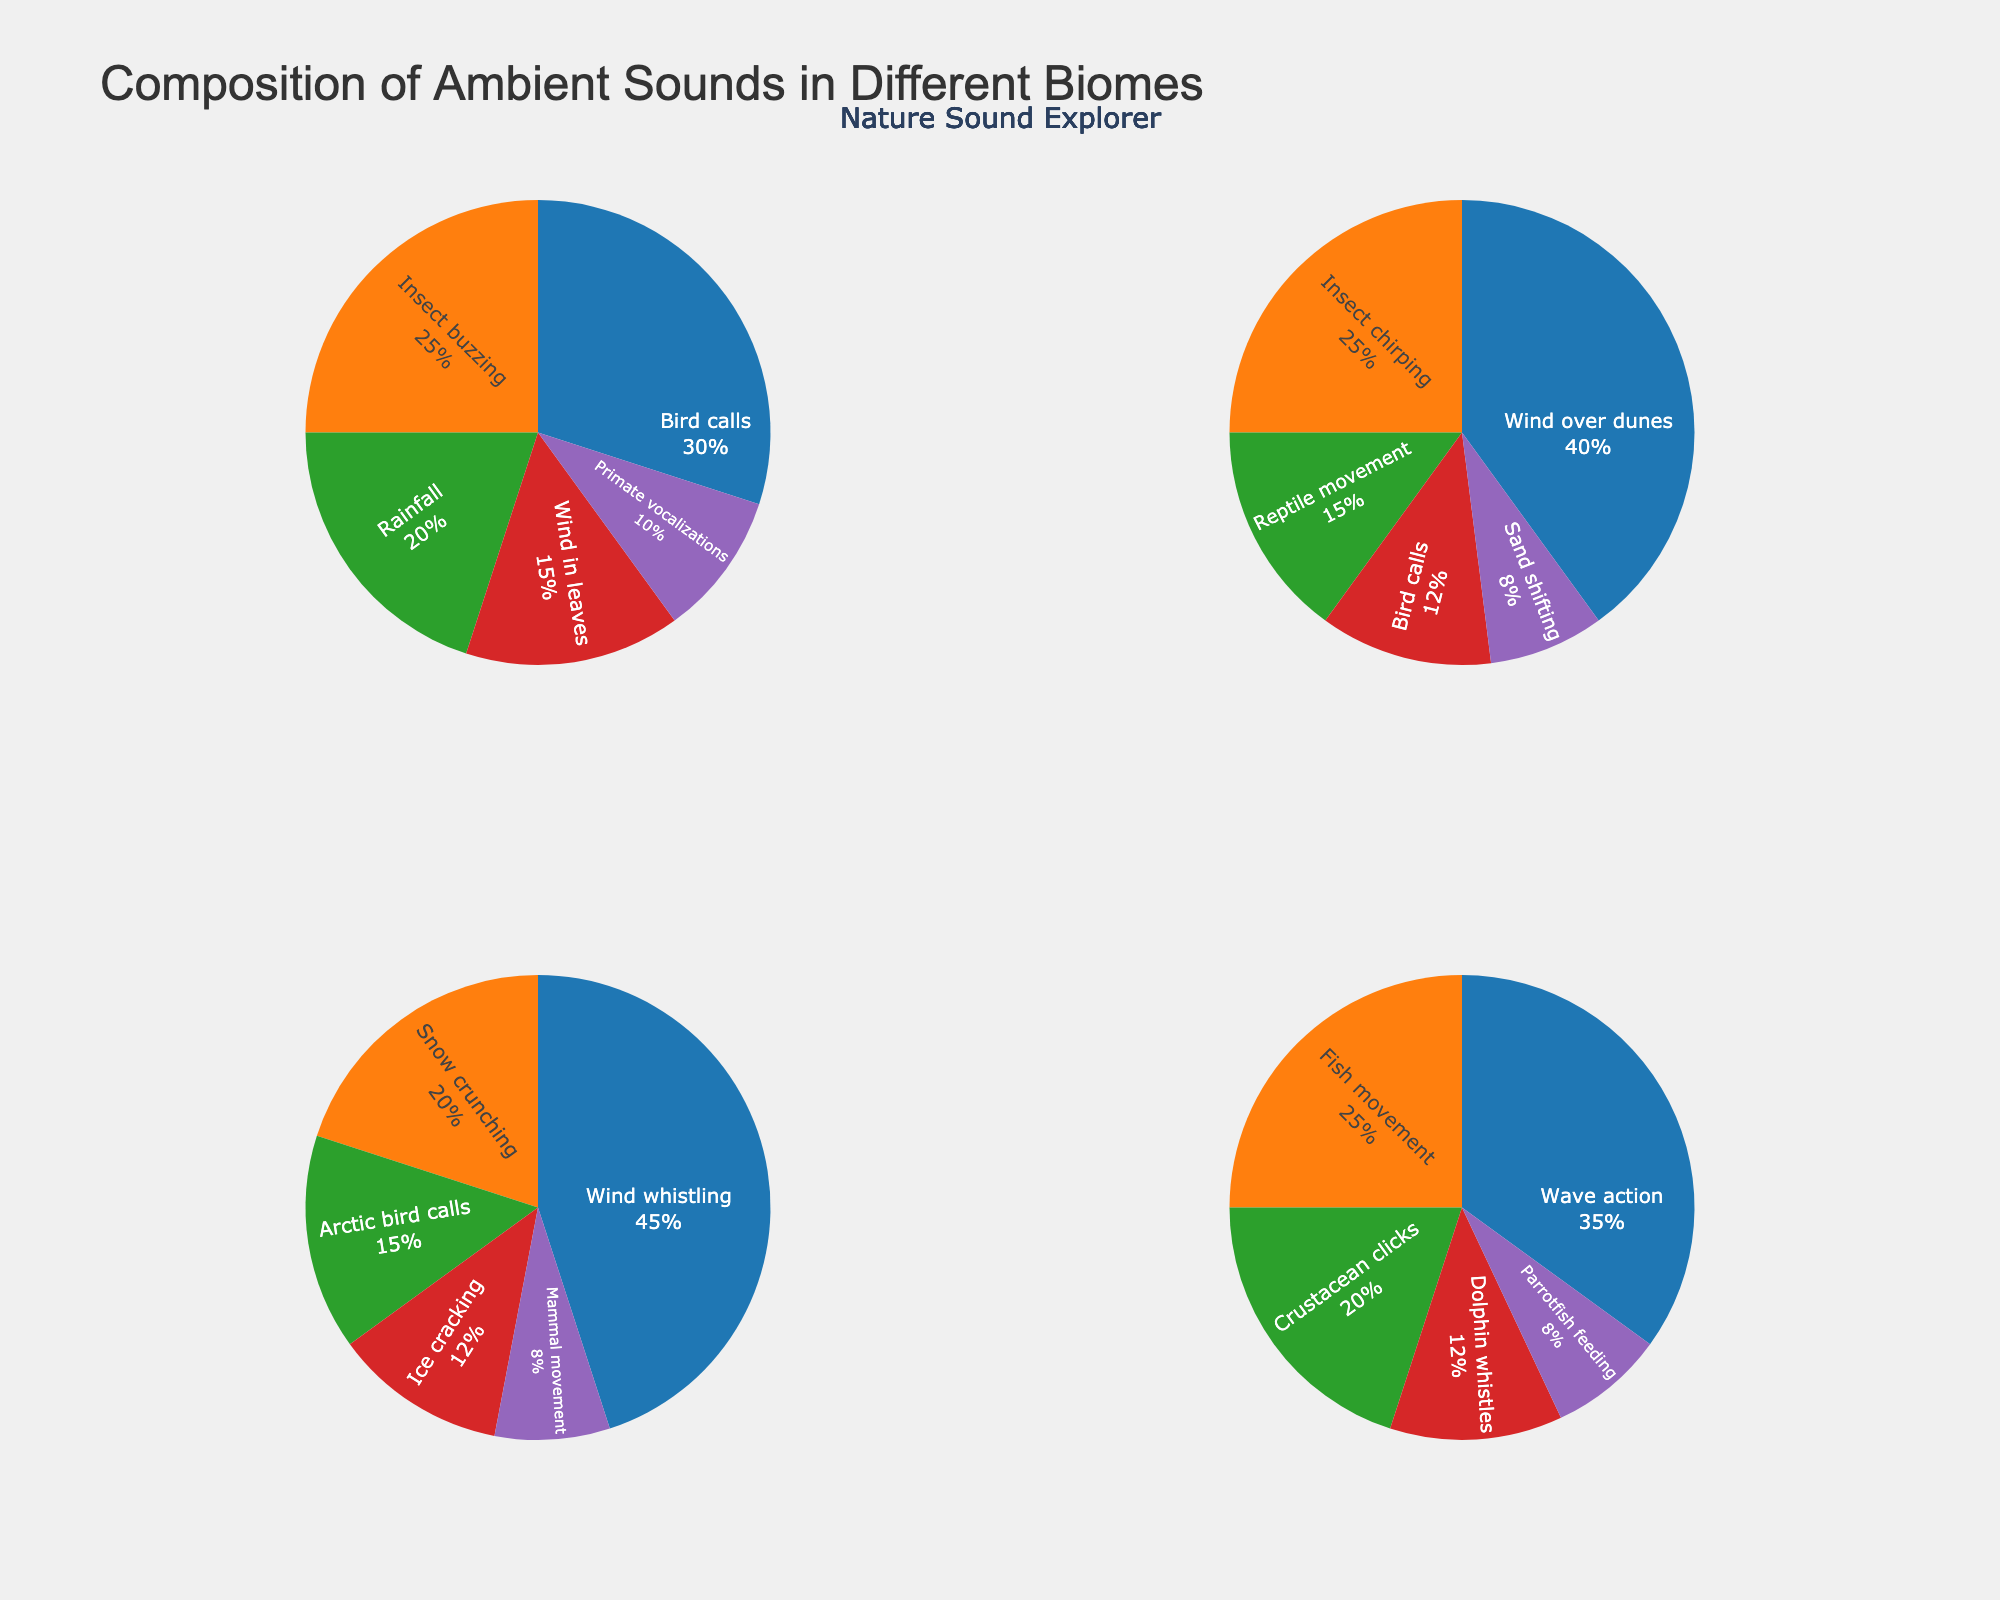What's the most common sound source in the rainforest? The pie chart segment with the largest percentage for the rainforest biome is labeled "Bird calls" at 30%. This indicates that bird calls are the most common sound source in the rainforest.
Answer: Bird calls Which biome has the highest percentage of sound coming from wind-related sources? The tundra biome has a segment labeled "Wind whistling" at 45%, which is the highest percentage compared to wind-related sources in other biomes.
Answer: Tundra What is the combined percentage of insect-related sounds in both rainforest and desert biomes? In the rainforest biome, "Insect buzzing" is 25%. In the desert biome, "Insect chirping" is 25%. Adding these together gives 25% + 25% = 50%.
Answer: 50% Which sound source constitutes the largest part of the coral reef biome? The pie chart segment with the largest percentage for the coral reef biome is labeled "Wave action" at 35%.
Answer: Wave action How do the sound compositions of bird calls in the rainforest and desert compare? In the rainforest, bird calls are 30%, while in the desert, bird calls are 12%. Comparing the two, bird calls are more common in the rainforest than in the desert.
Answer: More common in the rainforest What is the total percentage of all top sound sources (those with the highest individual percentages) across all biomes? Rainforest: Bird calls (30%), Desert: Wind over dunes (40%), Tundra: Wind whistling (45%), Coral reef: Wave action (35%). Adding these together gives 30% + 40% + 45% + 35% = 150%.
Answer: 150% Which biome has the most variety of sound sources, and how many are there? Each pie chart segment represents a distinct sound source within a biome. The rainforest has five sound sources, more than any other biome.
Answer: Rainforest, 5 In the tundra, how does the percentage of mammal movement compare to ice cracking? In the tundra biome, mammal movement is 8% while ice cracking is 12%. Mammal movement is less common than ice cracking.
Answer: Less common What is the difference in the percentage of sound from the wind in the tundra compared to the desert? In the tundra, "Wind whistling" is 45%, while "Wind over dunes" in the desert is 40%. The difference is 45% - 40% = 5%.
Answer: 5% Between rain and crustacean clicks, which is more prevalent in their respective biomes? Rainfall makes up 20% of the rainforest sounds, while crustacean clicks constitute 20% of coral reef sounds. They are equally prevalent in their respective biomes.
Answer: Equally prevalent 